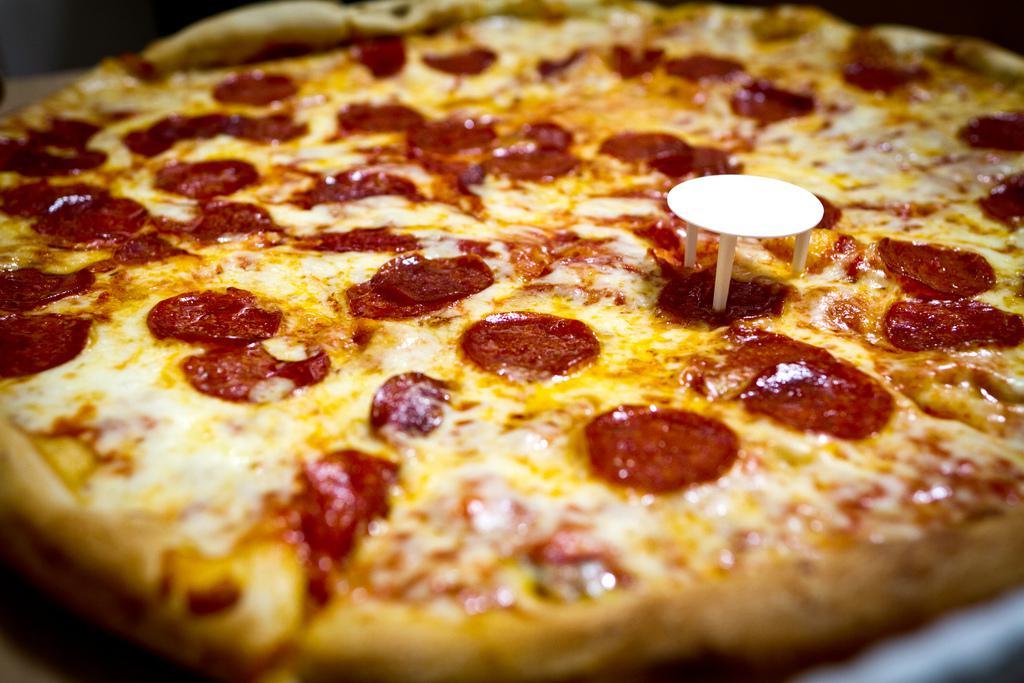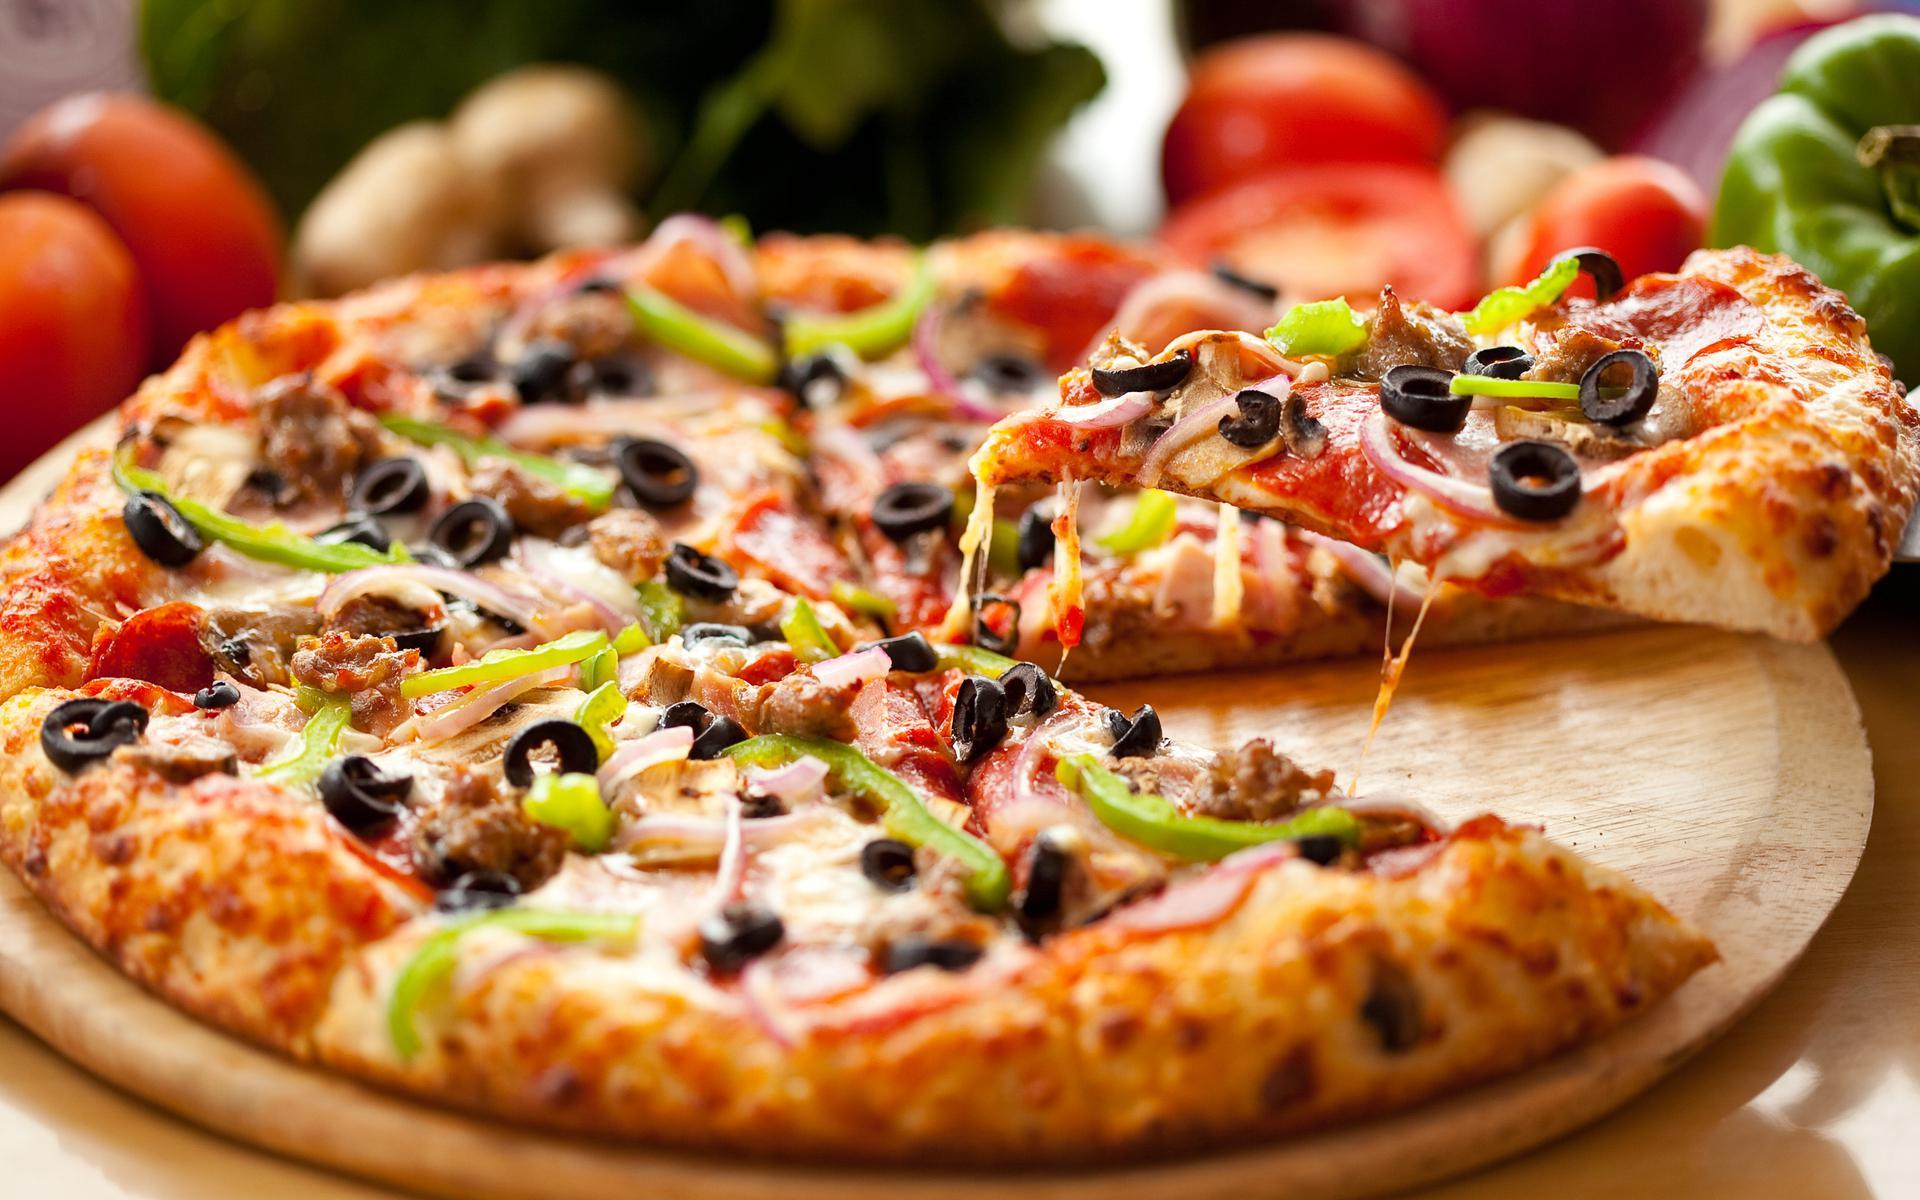The first image is the image on the left, the second image is the image on the right. Considering the images on both sides, is "One pizza is pepperoni and the other has some green peppers." valid? Answer yes or no. Yes. The first image is the image on the left, the second image is the image on the right. For the images displayed, is the sentence "In one of the images there are tomatoes visible on the table." factually correct? Answer yes or no. Yes. 